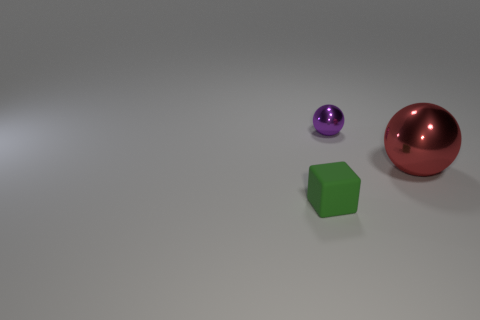Are there any other things that have the same material as the tiny green thing?
Provide a short and direct response. No. What number of purple objects have the same material as the tiny green thing?
Your answer should be compact. 0. There is another thing that is made of the same material as the small purple thing; what color is it?
Your answer should be compact. Red. Do the object to the left of the small metallic sphere and the tiny metal ball have the same color?
Provide a short and direct response. No. There is a sphere that is in front of the purple metal ball; what is its material?
Your answer should be compact. Metal. Are there an equal number of tiny purple metal things in front of the tiny rubber cube and tiny brown shiny balls?
Your answer should be compact. Yes. How many other small metallic balls are the same color as the tiny metallic ball?
Give a very brief answer. 0. The other small thing that is the same shape as the red metallic thing is what color?
Keep it short and to the point. Purple. Does the cube have the same size as the purple metallic thing?
Provide a short and direct response. Yes. Are there the same number of small matte things left of the small matte block and small metallic things that are in front of the big red shiny sphere?
Keep it short and to the point. Yes. 